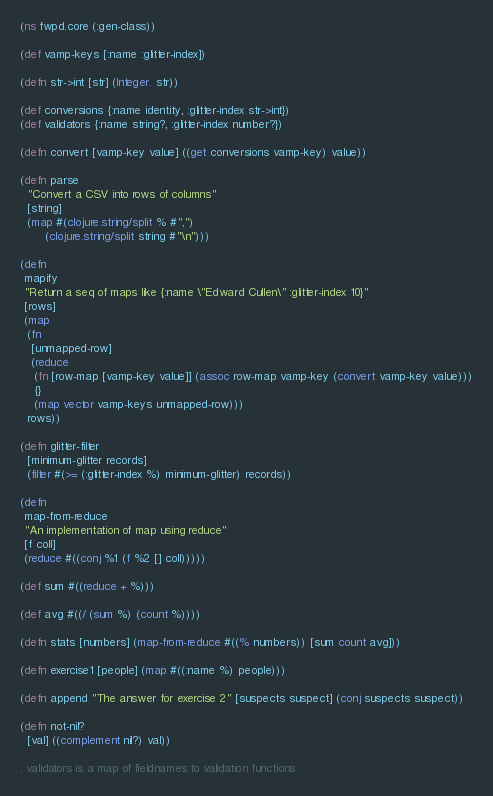<code> <loc_0><loc_0><loc_500><loc_500><_Clojure_>(ns fwpd.core (:gen-class))

(def vamp-keys [:name :glitter-index])

(defn str->int [str] (Integer. str))

(def conversions {:name identity, :glitter-index str->int})
(def validators {:name string?, :glitter-index number?})

(defn convert [vamp-key value] ((get conversions vamp-key) value))

(defn parse
  "Convert a CSV into rows of columns"
  [string]
  (map #(clojure.string/split % #",")
       (clojure.string/split string #"\n")))

(defn
 mapify
 "Return a seq of maps like {:name \"Edward Cullen\" :glitter-index 10}"
 [rows]
 (map
  (fn
   [unmapped-row]
   (reduce
    (fn [row-map [vamp-key value]] (assoc row-map vamp-key (convert vamp-key value)))
    {}
    (map vector vamp-keys unmapped-row)))
  rows))

(defn glitter-filter
  [minimum-glitter records]
  (filter #(>= (:glitter-index %) minimum-glitter) records))

(defn
 map-from-reduce
 "An implementation of map using reduce"
 [f coll]
 (reduce #((conj %1 (f %2 [] coll)))))

(def sum #((reduce + %)))

(def avg #((/ (sum %) (count %))))

(defn stats [numbers] (map-from-reduce #((% numbers)) [sum count avg]))

(defn exercise1 [people] (map #((:name %) people)))

(defn append "The answer for exercise 2" [suspects suspect] (conj suspects suspect))

(defn not-nil?
  [val] ((complement nil?) val))

; validators is a map of fieldnames to validation functions</code> 